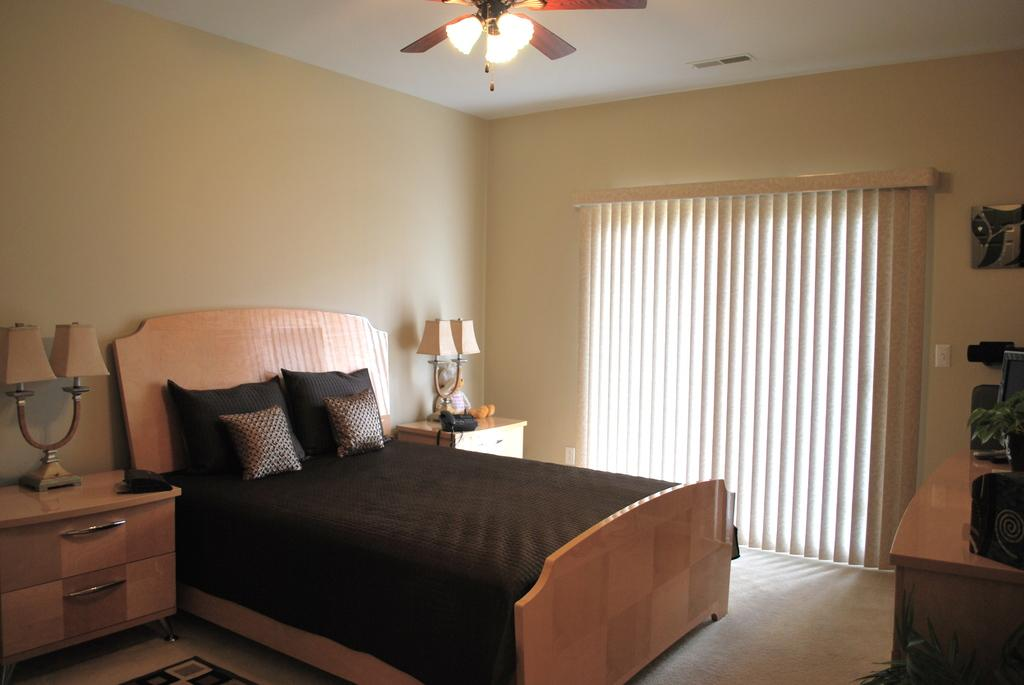What type of furniture is present in the image? There is a bed in the image. What is placed on the bed? There are pillows on the bed. What type of lighting is present in the image? There are lamps in the image. What type of toy can be seen in the image? There is a toy in the image. Where is the landline phone located in the image? The landline phone is on a cupboard in the image. What type of window treatment is present in the image? There is a curtain in the image. What type of structure is visible in the image? There is a wall in the image. What objects are present on a table in the image? There are objects on a table in the image. What type of lighting is visible in the image? There are lights visible in the image. Can you tell me how many eggs the zebra is holding in the image? There is no zebra or eggs present in the image. Is there any indication of an attack happening in the image? There is no indication of an attack or any aggressive behavior in the image. 